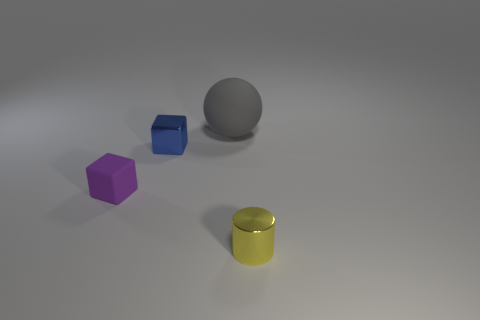What number of yellow objects are big spheres or small cylinders?
Provide a short and direct response. 1. There is a matte object to the left of the cube on the right side of the cube that is in front of the small metallic cube; what is its size?
Give a very brief answer. Small. The shiny object that is the same shape as the tiny rubber object is what size?
Make the answer very short. Small. How many large objects are either yellow shiny objects or green rubber cylinders?
Give a very brief answer. 0. Are the small thing that is on the right side of the gray matte sphere and the tiny cube on the left side of the blue metallic thing made of the same material?
Offer a terse response. No. What material is the cube that is on the left side of the small blue metal object?
Ensure brevity in your answer.  Rubber. How many metallic things are either purple cubes or small things?
Offer a terse response. 2. There is a small metallic object left of the tiny metal thing in front of the tiny blue metal block; what color is it?
Make the answer very short. Blue. Is the big thing made of the same material as the tiny block that is on the left side of the small blue metal object?
Give a very brief answer. Yes. What is the color of the rubber thing behind the rubber thing that is left of the tiny metal thing that is on the left side of the tiny yellow metallic cylinder?
Your answer should be compact. Gray. 